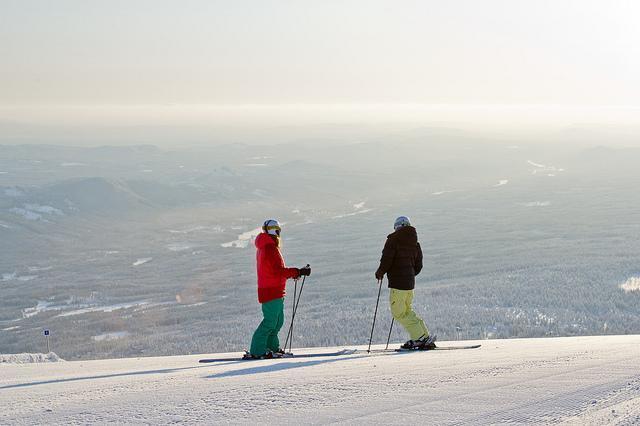How many skiers are on the slope?
Give a very brief answer. 2. How many people are in the picture?
Give a very brief answer. 2. How many ears does the bear have?
Give a very brief answer. 0. 